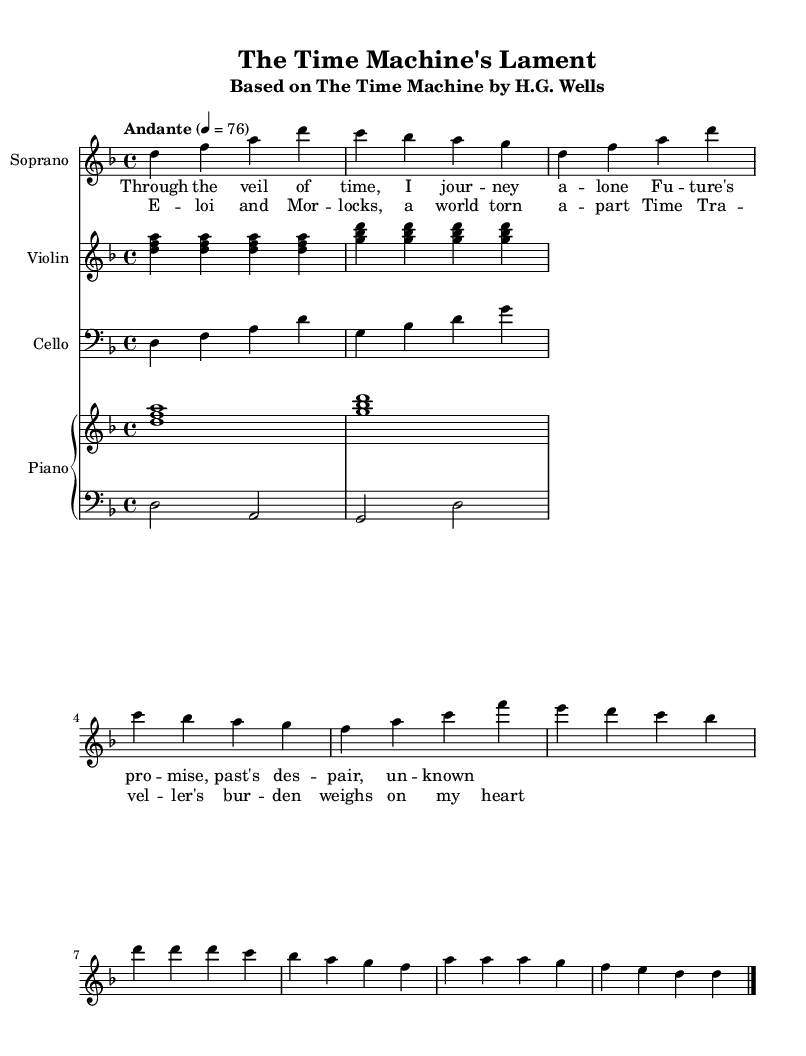What is the key signature of this music? The key signature is D minor, which has one flat (B flat) indicated in the key signature section at the beginning of the score.
Answer: D minor What is the time signature of this piece? The time signature is 4/4, which is displayed at the beginning of the score. This indicates that there are four beats in each measure and the quarter note receives one beat.
Answer: 4/4 What is the tempo marking for this score? The tempo marking is Andante, which suggests a moderate pace of around 76 beats per minute. This is indicated just below the time signature in the score.
Answer: Andante How many staves are used in this score? There are four staves in total: one for Soprano, one for Violin, one for Cello, and one Piano staff which is split into two (right and left). This is indicated in the layout section of the score.
Answer: Four What instrument plays the simplified arpeggiated figures? The simplified arpeggiated figures are played by the Violin and the Piano (both right and left hands), as denoted in their respective staves.
Answer: Violin and Piano What is the name of the song based on the classical novel? The song is titled "The Time Machine's Lament," as specified in the header section of the score.
Answer: The Time Machine's Lament What is the overall mood suggested by the title and lyrics? The mood suggested by the title and lyrics, which speak of journeying through time and emotional burdens, is one of melancholy or reflection, fitting for an operatic interpretation.
Answer: Melancholy 